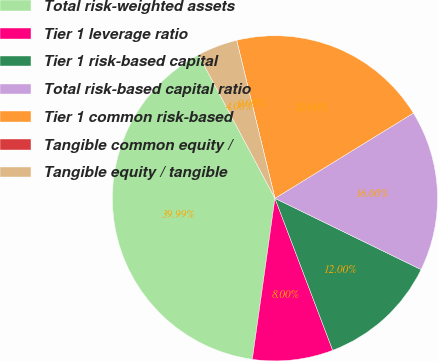Convert chart. <chart><loc_0><loc_0><loc_500><loc_500><pie_chart><fcel>Total risk-weighted assets<fcel>Tier 1 leverage ratio<fcel>Tier 1 risk-based capital<fcel>Total risk-based capital ratio<fcel>Tier 1 common risk-based<fcel>Tangible common equity /<fcel>Tangible equity / tangible<nl><fcel>39.99%<fcel>8.0%<fcel>12.0%<fcel>16.0%<fcel>20.0%<fcel>0.0%<fcel>4.0%<nl></chart> 